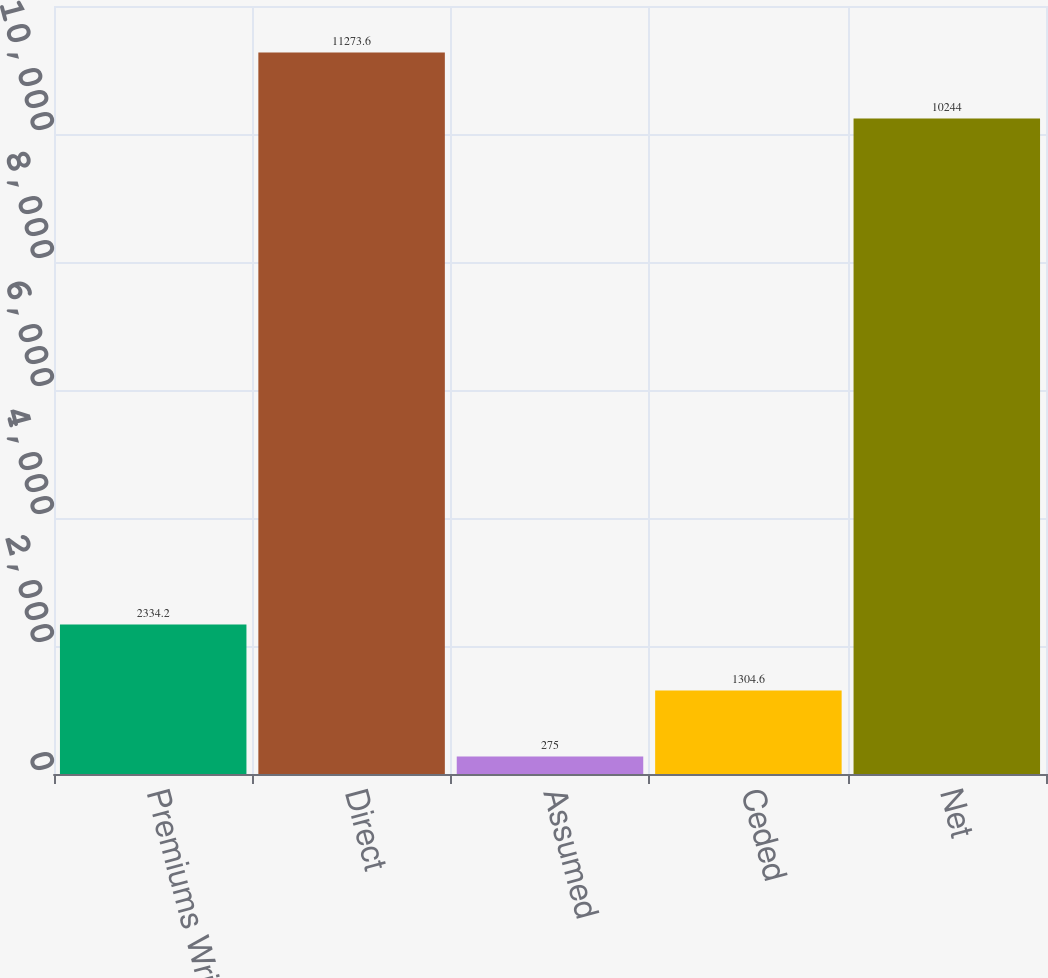Convert chart. <chart><loc_0><loc_0><loc_500><loc_500><bar_chart><fcel>Premiums Written<fcel>Direct<fcel>Assumed<fcel>Ceded<fcel>Net<nl><fcel>2334.2<fcel>11273.6<fcel>275<fcel>1304.6<fcel>10244<nl></chart> 